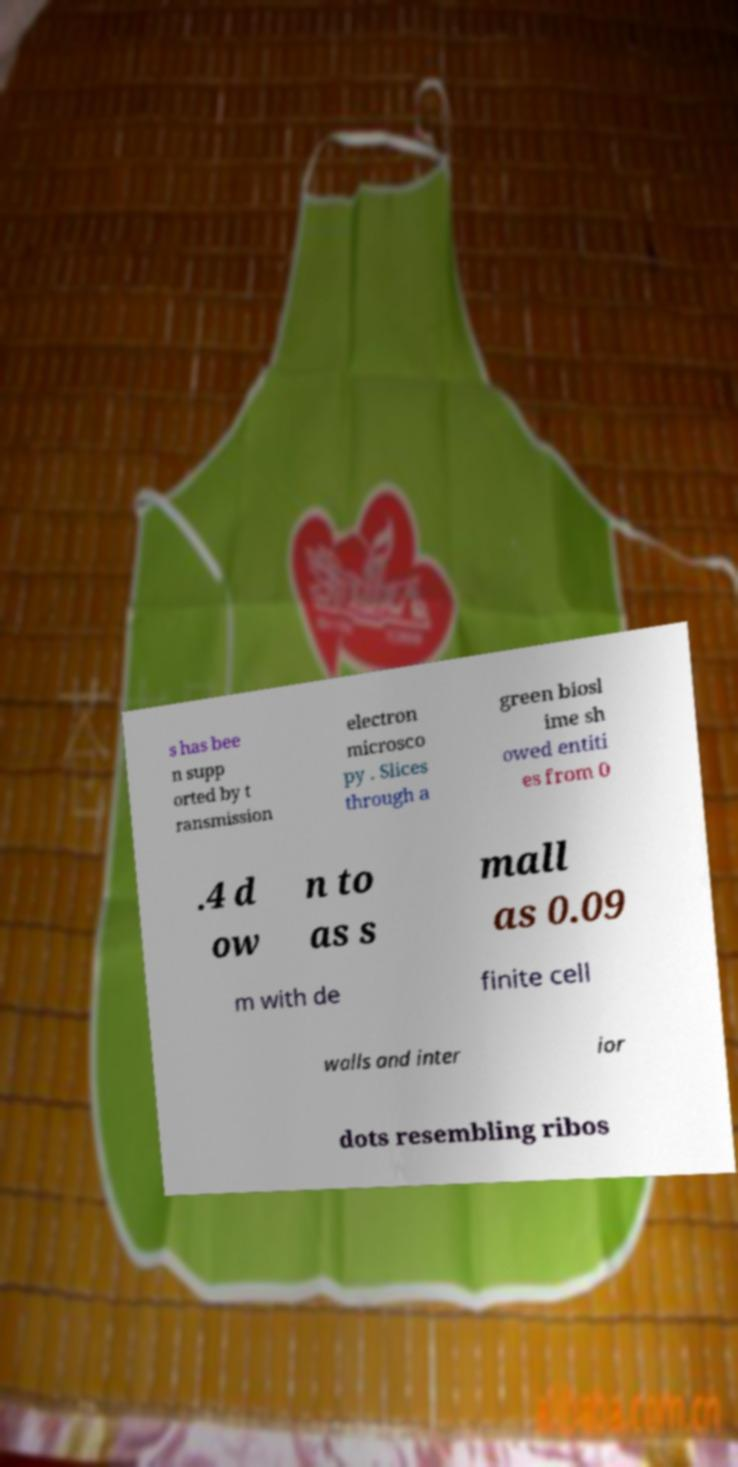Can you accurately transcribe the text from the provided image for me? s has bee n supp orted by t ransmission electron microsco py . Slices through a green biosl ime sh owed entiti es from 0 .4 d ow n to as s mall as 0.09 m with de finite cell walls and inter ior dots resembling ribos 